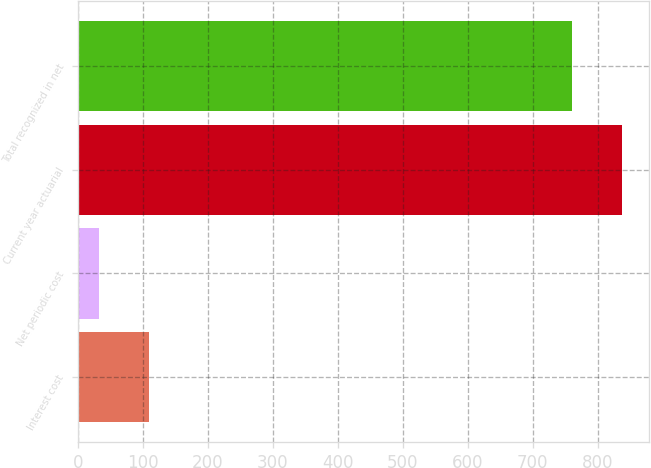Convert chart to OTSL. <chart><loc_0><loc_0><loc_500><loc_500><bar_chart><fcel>Interest cost<fcel>Net periodic cost<fcel>Current year actuarial<fcel>Total recognized in net<nl><fcel>109.5<fcel>32<fcel>837.5<fcel>760<nl></chart> 